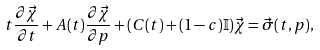Convert formula to latex. <formula><loc_0><loc_0><loc_500><loc_500>t \frac { \partial \vec { \chi } } { \partial t } + A ( t ) \frac { \partial \vec { \chi } } { \partial p } + ( C ( t ) + ( 1 - c ) \mathbb { I } ) \vec { \chi } = \vec { \sigma } ( t , p ) ,</formula> 